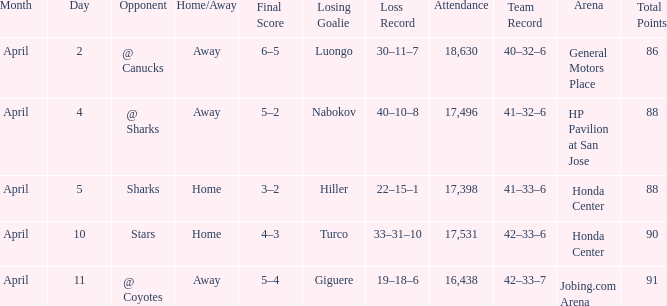How many Points have a Score of 3–2, and an Attendance larger than 17,398? None. 